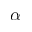<formula> <loc_0><loc_0><loc_500><loc_500>\alpha</formula> 